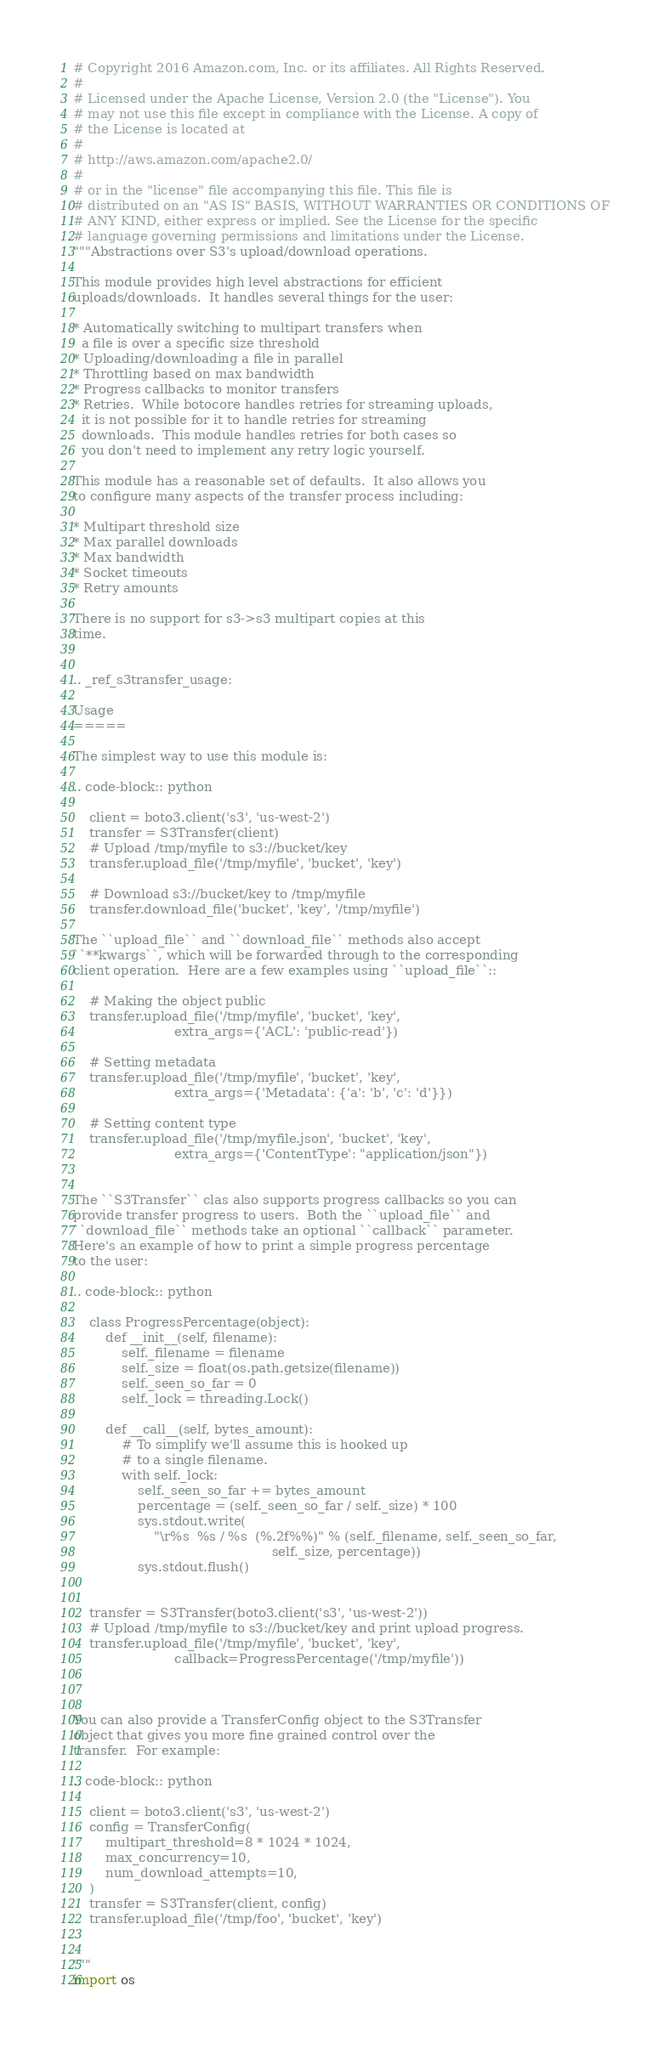<code> <loc_0><loc_0><loc_500><loc_500><_Python_># Copyright 2016 Amazon.com, Inc. or its affiliates. All Rights Reserved.
#
# Licensed under the Apache License, Version 2.0 (the "License"). You
# may not use this file except in compliance with the License. A copy of
# the License is located at
#
# http://aws.amazon.com/apache2.0/
#
# or in the "license" file accompanying this file. This file is
# distributed on an "AS IS" BASIS, WITHOUT WARRANTIES OR CONDITIONS OF
# ANY KIND, either express or implied. See the License for the specific
# language governing permissions and limitations under the License.
"""Abstractions over S3's upload/download operations.

This module provides high level abstractions for efficient
uploads/downloads.  It handles several things for the user:

* Automatically switching to multipart transfers when
  a file is over a specific size threshold
* Uploading/downloading a file in parallel
* Throttling based on max bandwidth
* Progress callbacks to monitor transfers
* Retries.  While botocore handles retries for streaming uploads,
  it is not possible for it to handle retries for streaming
  downloads.  This module handles retries for both cases so
  you don't need to implement any retry logic yourself.

This module has a reasonable set of defaults.  It also allows you
to configure many aspects of the transfer process including:

* Multipart threshold size
* Max parallel downloads
* Max bandwidth
* Socket timeouts
* Retry amounts

There is no support for s3->s3 multipart copies at this
time.


.. _ref_s3transfer_usage:

Usage
=====

The simplest way to use this module is:

.. code-block:: python

    client = boto3.client('s3', 'us-west-2')
    transfer = S3Transfer(client)
    # Upload /tmp/myfile to s3://bucket/key
    transfer.upload_file('/tmp/myfile', 'bucket', 'key')

    # Download s3://bucket/key to /tmp/myfile
    transfer.download_file('bucket', 'key', '/tmp/myfile')

The ``upload_file`` and ``download_file`` methods also accept
``**kwargs``, which will be forwarded through to the corresponding
client operation.  Here are a few examples using ``upload_file``::

    # Making the object public
    transfer.upload_file('/tmp/myfile', 'bucket', 'key',
                         extra_args={'ACL': 'public-read'})

    # Setting metadata
    transfer.upload_file('/tmp/myfile', 'bucket', 'key',
                         extra_args={'Metadata': {'a': 'b', 'c': 'd'}})

    # Setting content type
    transfer.upload_file('/tmp/myfile.json', 'bucket', 'key',
                         extra_args={'ContentType': "application/json"})


The ``S3Transfer`` clas also supports progress callbacks so you can
provide transfer progress to users.  Both the ``upload_file`` and
``download_file`` methods take an optional ``callback`` parameter.
Here's an example of how to print a simple progress percentage
to the user:

.. code-block:: python

    class ProgressPercentage(object):
        def __init__(self, filename):
            self._filename = filename
            self._size = float(os.path.getsize(filename))
            self._seen_so_far = 0
            self._lock = threading.Lock()

        def __call__(self, bytes_amount):
            # To simplify we'll assume this is hooked up
            # to a single filename.
            with self._lock:
                self._seen_so_far += bytes_amount
                percentage = (self._seen_so_far / self._size) * 100
                sys.stdout.write(
                    "\r%s  %s / %s  (%.2f%%)" % (self._filename, self._seen_so_far,
                                                 self._size, percentage))
                sys.stdout.flush()


    transfer = S3Transfer(boto3.client('s3', 'us-west-2'))
    # Upload /tmp/myfile to s3://bucket/key and print upload progress.
    transfer.upload_file('/tmp/myfile', 'bucket', 'key',
                         callback=ProgressPercentage('/tmp/myfile'))



You can also provide a TransferConfig object to the S3Transfer
object that gives you more fine grained control over the
transfer.  For example:

.. code-block:: python

    client = boto3.client('s3', 'us-west-2')
    config = TransferConfig(
        multipart_threshold=8 * 1024 * 1024,
        max_concurrency=10,
        num_download_attempts=10,
    )
    transfer = S3Transfer(client, config)
    transfer.upload_file('/tmp/foo', 'bucket', 'key')


"""
import os</code> 